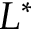<formula> <loc_0><loc_0><loc_500><loc_500>L ^ { \ast }</formula> 